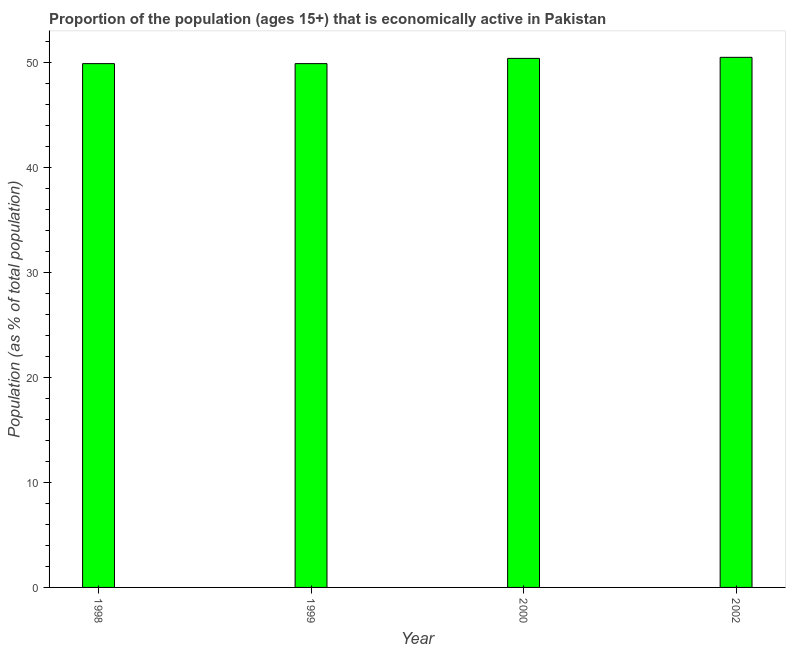Does the graph contain grids?
Your answer should be very brief. No. What is the title of the graph?
Your response must be concise. Proportion of the population (ages 15+) that is economically active in Pakistan. What is the label or title of the X-axis?
Provide a succinct answer. Year. What is the label or title of the Y-axis?
Offer a very short reply. Population (as % of total population). What is the percentage of economically active population in 2002?
Provide a succinct answer. 50.5. Across all years, what is the maximum percentage of economically active population?
Provide a short and direct response. 50.5. Across all years, what is the minimum percentage of economically active population?
Your response must be concise. 49.9. In which year was the percentage of economically active population maximum?
Your response must be concise. 2002. What is the sum of the percentage of economically active population?
Make the answer very short. 200.7. What is the difference between the percentage of economically active population in 1998 and 2000?
Keep it short and to the point. -0.5. What is the average percentage of economically active population per year?
Your response must be concise. 50.17. What is the median percentage of economically active population?
Provide a succinct answer. 50.15. Do a majority of the years between 2002 and 1998 (inclusive) have percentage of economically active population greater than 50 %?
Ensure brevity in your answer.  Yes. Is the percentage of economically active population in 1999 less than that in 2000?
Provide a succinct answer. Yes. What is the difference between the highest and the second highest percentage of economically active population?
Your answer should be very brief. 0.1. Is the sum of the percentage of economically active population in 1998 and 1999 greater than the maximum percentage of economically active population across all years?
Ensure brevity in your answer.  Yes. What is the difference between the highest and the lowest percentage of economically active population?
Provide a succinct answer. 0.6. In how many years, is the percentage of economically active population greater than the average percentage of economically active population taken over all years?
Your answer should be compact. 2. How many bars are there?
Offer a terse response. 4. How many years are there in the graph?
Your answer should be very brief. 4. Are the values on the major ticks of Y-axis written in scientific E-notation?
Provide a succinct answer. No. What is the Population (as % of total population) in 1998?
Ensure brevity in your answer.  49.9. What is the Population (as % of total population) of 1999?
Offer a terse response. 49.9. What is the Population (as % of total population) in 2000?
Make the answer very short. 50.4. What is the Population (as % of total population) of 2002?
Your answer should be compact. 50.5. What is the difference between the Population (as % of total population) in 1998 and 2002?
Provide a short and direct response. -0.6. What is the difference between the Population (as % of total population) in 1999 and 2000?
Your answer should be very brief. -0.5. What is the difference between the Population (as % of total population) in 1999 and 2002?
Provide a short and direct response. -0.6. What is the difference between the Population (as % of total population) in 2000 and 2002?
Give a very brief answer. -0.1. What is the ratio of the Population (as % of total population) in 1999 to that in 2000?
Your response must be concise. 0.99. What is the ratio of the Population (as % of total population) in 2000 to that in 2002?
Give a very brief answer. 1. 